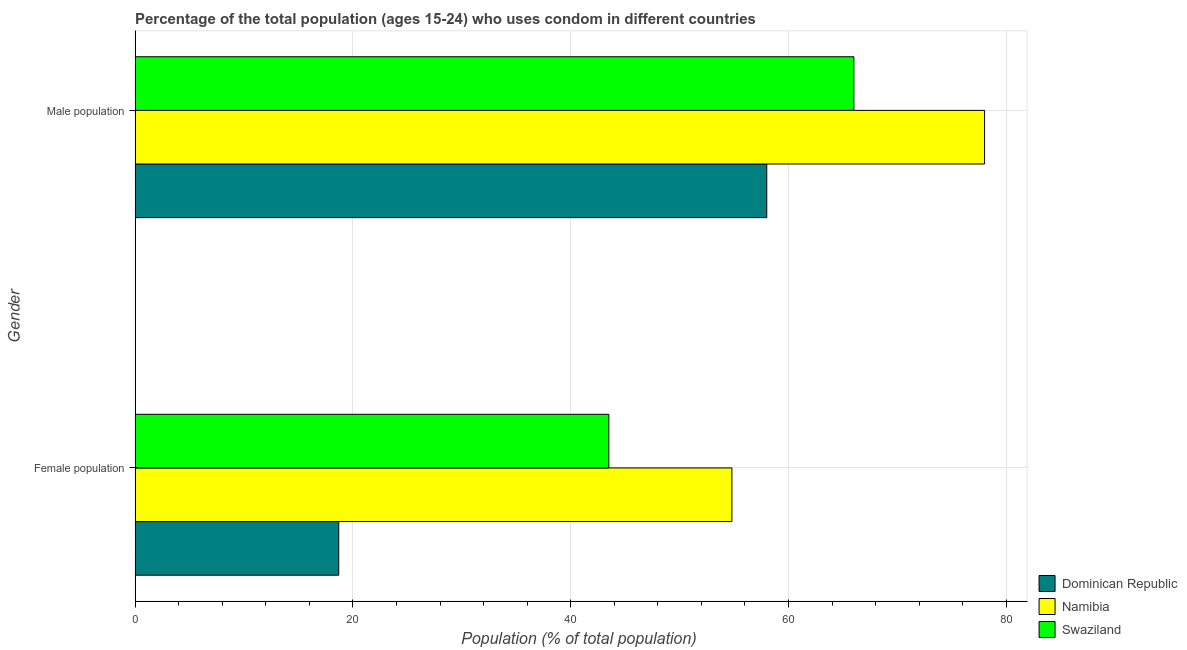How many different coloured bars are there?
Keep it short and to the point. 3. Are the number of bars per tick equal to the number of legend labels?
Your answer should be compact. Yes. Are the number of bars on each tick of the Y-axis equal?
Your answer should be very brief. Yes. How many bars are there on the 1st tick from the top?
Provide a short and direct response. 3. How many bars are there on the 1st tick from the bottom?
Provide a short and direct response. 3. What is the label of the 1st group of bars from the top?
Offer a terse response. Male population. What is the female population in Dominican Republic?
Make the answer very short. 18.7. Across all countries, what is the maximum male population?
Offer a very short reply. 78. In which country was the female population maximum?
Your answer should be very brief. Namibia. In which country was the female population minimum?
Give a very brief answer. Dominican Republic. What is the total male population in the graph?
Ensure brevity in your answer.  202. What is the difference between the female population in Namibia and that in Swaziland?
Ensure brevity in your answer.  11.3. What is the difference between the male population and female population in Dominican Republic?
Offer a terse response. 39.3. In how many countries, is the male population greater than 32 %?
Offer a terse response. 3. What is the ratio of the male population in Dominican Republic to that in Namibia?
Keep it short and to the point. 0.74. What does the 1st bar from the top in Male population represents?
Your response must be concise. Swaziland. What does the 2nd bar from the bottom in Male population represents?
Offer a terse response. Namibia. How many bars are there?
Ensure brevity in your answer.  6. Are all the bars in the graph horizontal?
Your answer should be very brief. Yes. How many countries are there in the graph?
Your answer should be very brief. 3. What is the difference between two consecutive major ticks on the X-axis?
Give a very brief answer. 20. Does the graph contain any zero values?
Your response must be concise. No. Does the graph contain grids?
Keep it short and to the point. Yes. Where does the legend appear in the graph?
Your response must be concise. Bottom right. How are the legend labels stacked?
Provide a succinct answer. Vertical. What is the title of the graph?
Give a very brief answer. Percentage of the total population (ages 15-24) who uses condom in different countries. What is the label or title of the X-axis?
Keep it short and to the point. Population (% of total population) . What is the Population (% of total population)  in Namibia in Female population?
Give a very brief answer. 54.8. What is the Population (% of total population)  in Swaziland in Female population?
Give a very brief answer. 43.5. What is the Population (% of total population)  of Namibia in Male population?
Keep it short and to the point. 78. What is the Population (% of total population)  in Swaziland in Male population?
Keep it short and to the point. 66. Across all Gender, what is the maximum Population (% of total population)  of Dominican Republic?
Give a very brief answer. 58. Across all Gender, what is the maximum Population (% of total population)  in Namibia?
Provide a short and direct response. 78. Across all Gender, what is the minimum Population (% of total population)  in Namibia?
Offer a terse response. 54.8. Across all Gender, what is the minimum Population (% of total population)  of Swaziland?
Give a very brief answer. 43.5. What is the total Population (% of total population)  of Dominican Republic in the graph?
Provide a short and direct response. 76.7. What is the total Population (% of total population)  of Namibia in the graph?
Provide a short and direct response. 132.8. What is the total Population (% of total population)  in Swaziland in the graph?
Your response must be concise. 109.5. What is the difference between the Population (% of total population)  in Dominican Republic in Female population and that in Male population?
Offer a very short reply. -39.3. What is the difference between the Population (% of total population)  in Namibia in Female population and that in Male population?
Give a very brief answer. -23.2. What is the difference between the Population (% of total population)  in Swaziland in Female population and that in Male population?
Provide a succinct answer. -22.5. What is the difference between the Population (% of total population)  of Dominican Republic in Female population and the Population (% of total population)  of Namibia in Male population?
Your answer should be very brief. -59.3. What is the difference between the Population (% of total population)  of Dominican Republic in Female population and the Population (% of total population)  of Swaziland in Male population?
Ensure brevity in your answer.  -47.3. What is the difference between the Population (% of total population)  in Namibia in Female population and the Population (% of total population)  in Swaziland in Male population?
Provide a succinct answer. -11.2. What is the average Population (% of total population)  of Dominican Republic per Gender?
Your answer should be very brief. 38.35. What is the average Population (% of total population)  in Namibia per Gender?
Your answer should be compact. 66.4. What is the average Population (% of total population)  of Swaziland per Gender?
Give a very brief answer. 54.75. What is the difference between the Population (% of total population)  of Dominican Republic and Population (% of total population)  of Namibia in Female population?
Give a very brief answer. -36.1. What is the difference between the Population (% of total population)  in Dominican Republic and Population (% of total population)  in Swaziland in Female population?
Provide a short and direct response. -24.8. What is the difference between the Population (% of total population)  of Namibia and Population (% of total population)  of Swaziland in Female population?
Make the answer very short. 11.3. What is the difference between the Population (% of total population)  in Dominican Republic and Population (% of total population)  in Namibia in Male population?
Make the answer very short. -20. What is the ratio of the Population (% of total population)  of Dominican Republic in Female population to that in Male population?
Keep it short and to the point. 0.32. What is the ratio of the Population (% of total population)  in Namibia in Female population to that in Male population?
Provide a short and direct response. 0.7. What is the ratio of the Population (% of total population)  of Swaziland in Female population to that in Male population?
Provide a short and direct response. 0.66. What is the difference between the highest and the second highest Population (% of total population)  of Dominican Republic?
Your response must be concise. 39.3. What is the difference between the highest and the second highest Population (% of total population)  in Namibia?
Your answer should be very brief. 23.2. What is the difference between the highest and the lowest Population (% of total population)  of Dominican Republic?
Your response must be concise. 39.3. What is the difference between the highest and the lowest Population (% of total population)  in Namibia?
Offer a very short reply. 23.2. What is the difference between the highest and the lowest Population (% of total population)  in Swaziland?
Provide a short and direct response. 22.5. 